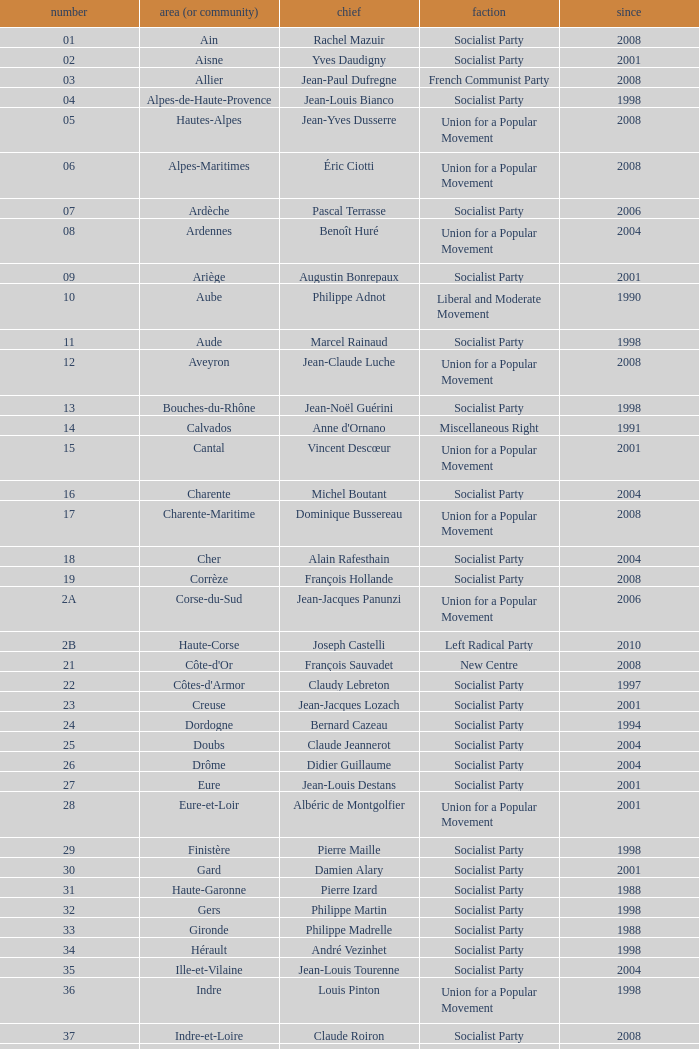Who is the president from the Union for a Popular Movement party that represents the Hautes-Alpes department? Jean-Yves Dusserre. 